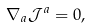<formula> <loc_0><loc_0><loc_500><loc_500>\nabla _ { a } \mathcal { J } ^ { a } = 0 ,</formula> 